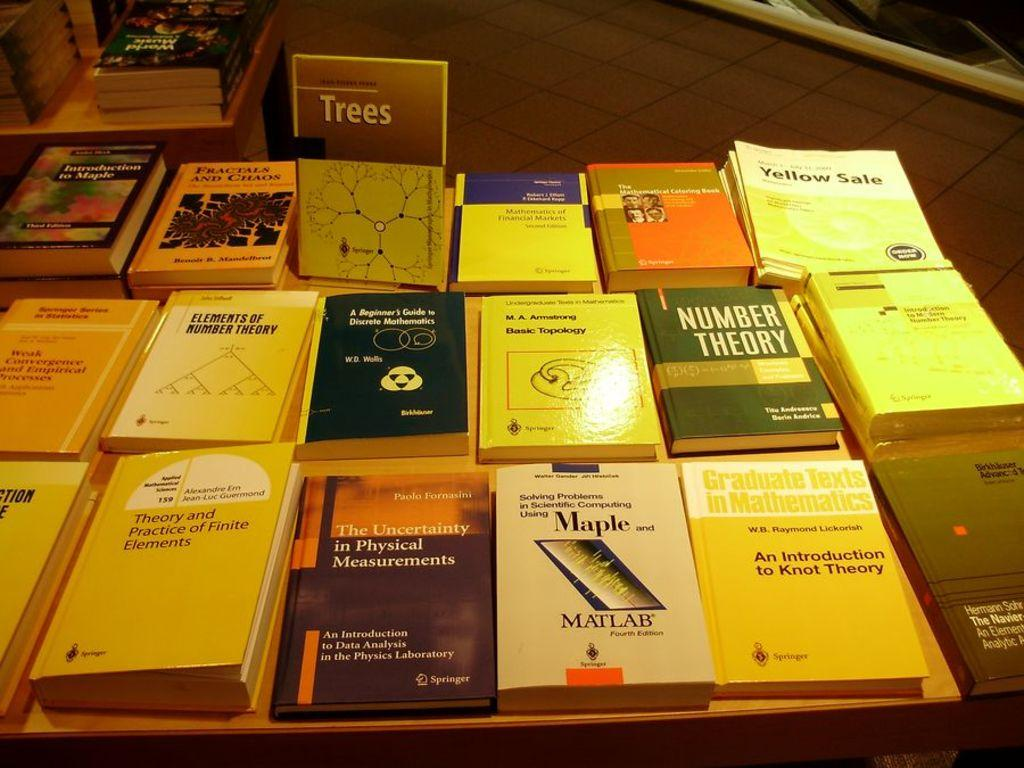Provide a one-sentence caption for the provided image. Many mathematics books are among the literature on the table. 